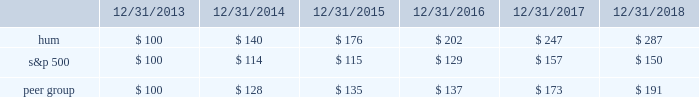Stock total return performance the following graph compares our total return to stockholders with the returns of the standard & poor 2019s composite 500 index ( 201cs&p 500 201d ) and the dow jones us select health care providers index ( 201cpeer group 201d ) for the five years ended december 31 , 2018 .
The graph assumes an investment of $ 100 in each of our common stock , the s&p 500 , and the peer group on december 31 , 2013 , and that dividends were reinvested when paid. .
The stock price performance included in this graph is not necessarily indicative of future stock price performance. .
What was the percent of the of the growth for stock total return performance for hum from 2016 to 2017? 
Rationale: the stock total return performance for hum increased by 22.3% from 2016 to 2017
Computations: ((247 - 202) / 202)
Answer: 0.22277. 